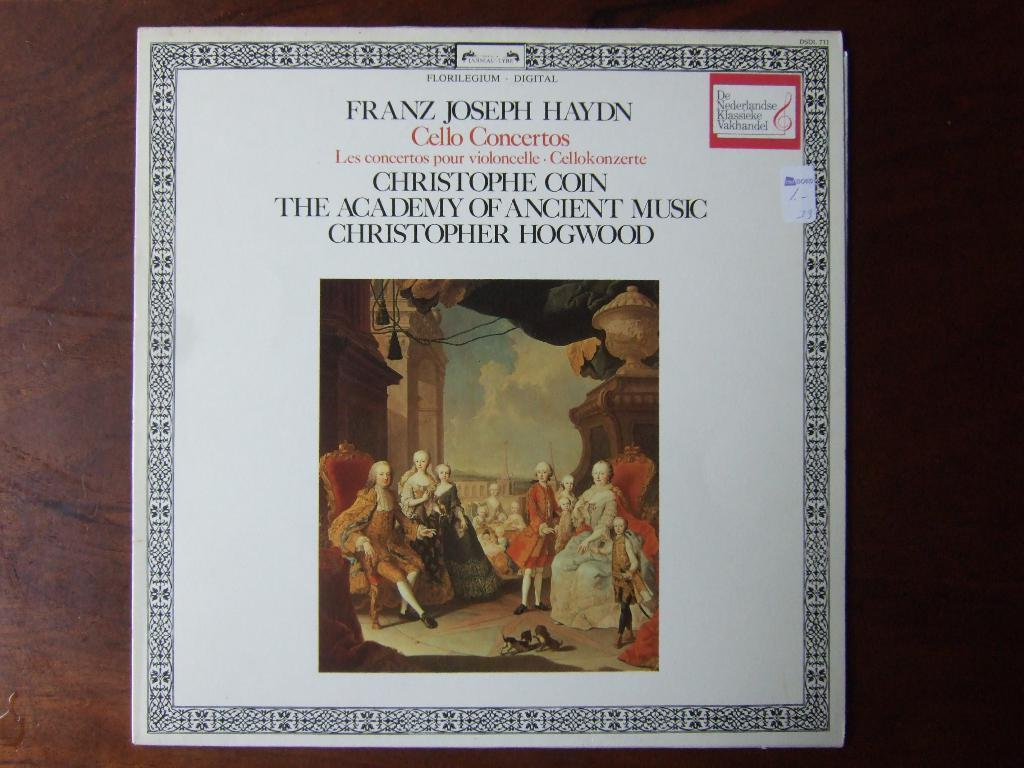<image>
Render a clear and concise summary of the photo. A CD cover for classical music for Franz Joseph Hayden. 